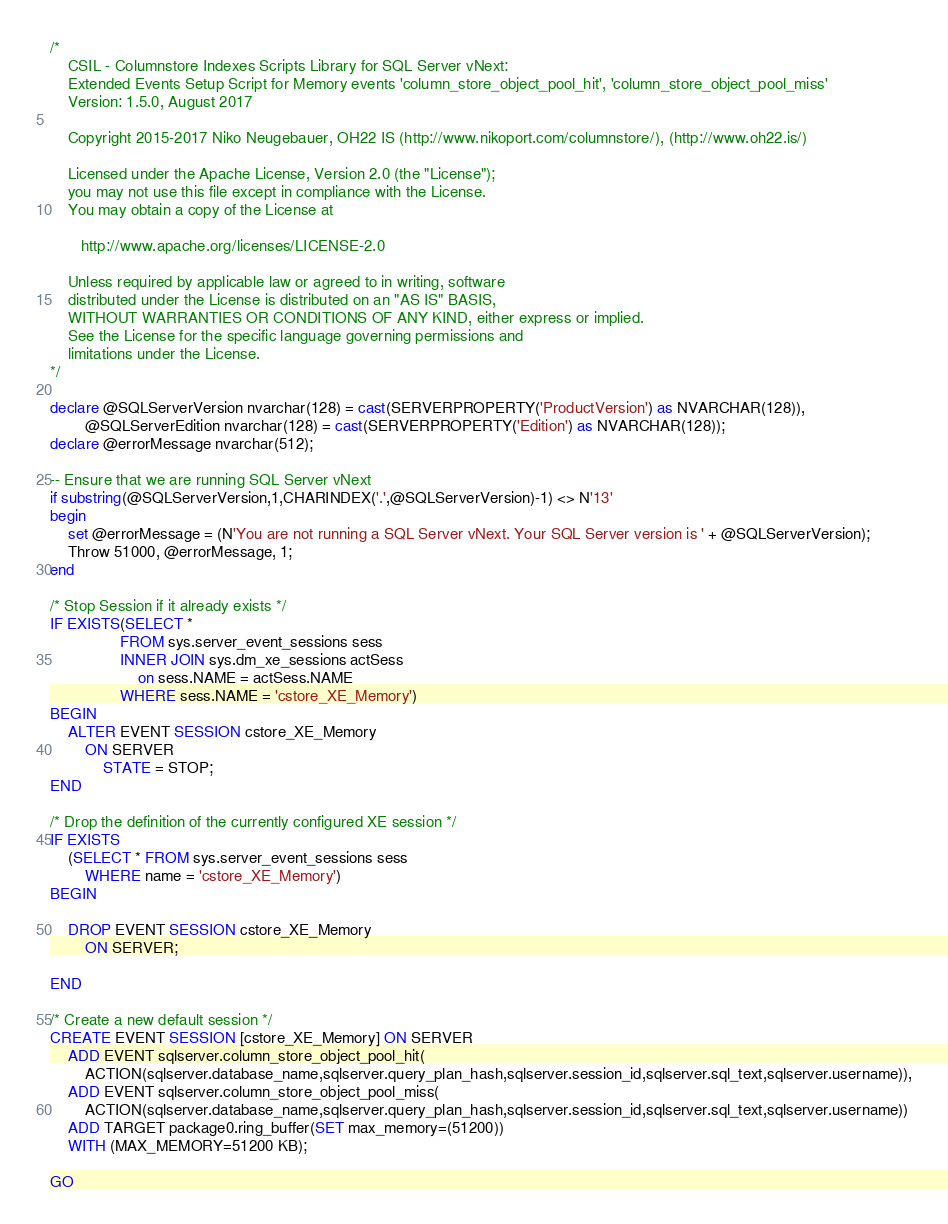Convert code to text. <code><loc_0><loc_0><loc_500><loc_500><_SQL_>/*
	CSIL - Columnstore Indexes Scripts Library for SQL Server vNext: 
	Extended Events Setup Script for Memory events 'column_store_object_pool_hit', 'column_store_object_pool_miss'
	Version: 1.5.0, August 2017

	Copyright 2015-2017 Niko Neugebauer, OH22 IS (http://www.nikoport.com/columnstore/), (http://www.oh22.is/)

	Licensed under the Apache License, Version 2.0 (the "License");
	you may not use this file except in compliance with the License.
	You may obtain a copy of the License at

       http://www.apache.org/licenses/LICENSE-2.0

    Unless required by applicable law or agreed to in writing, software
    distributed under the License is distributed on an "AS IS" BASIS,
    WITHOUT WARRANTIES OR CONDITIONS OF ANY KIND, either express or implied.
    See the License for the specific language governing permissions and
    limitations under the License.
*/

declare @SQLServerVersion nvarchar(128) = cast(SERVERPROPERTY('ProductVersion') as NVARCHAR(128)), 
		@SQLServerEdition nvarchar(128) = cast(SERVERPROPERTY('Edition') as NVARCHAR(128));
declare @errorMessage nvarchar(512);

-- Ensure that we are running SQL Server vNext
if substring(@SQLServerVersion,1,CHARINDEX('.',@SQLServerVersion)-1) <> N'13'
begin
	set @errorMessage = (N'You are not running a SQL Server vNext. Your SQL Server version is ' + @SQLServerVersion);
	Throw 51000, @errorMessage, 1;
end

/* Stop Session if it already exists */
IF EXISTS(SELECT *
				FROM sys.server_event_sessions sess
				INNER JOIN sys.dm_xe_sessions actSess
					on sess.NAME = actSess.NAME
				WHERE sess.NAME = 'cstore_XE_Memory')
BEGIN
	ALTER EVENT SESSION cstore_XE_Memory
		ON SERVER 
			STATE = STOP;
END

/* Drop the definition of the currently configured XE session */
IF EXISTS
    (SELECT * FROM sys.server_event_sessions sess
        WHERE name = 'cstore_XE_Memory')
BEGIN

    DROP EVENT SESSION cstore_XE_Memory
        ON SERVER;
	
END

/* Create a new default session */
CREATE EVENT SESSION [cstore_XE_Memory] ON SERVER 
	ADD EVENT sqlserver.column_store_object_pool_hit(
		ACTION(sqlserver.database_name,sqlserver.query_plan_hash,sqlserver.session_id,sqlserver.sql_text,sqlserver.username)),
	ADD EVENT sqlserver.column_store_object_pool_miss(
		ACTION(sqlserver.database_name,sqlserver.query_plan_hash,sqlserver.session_id,sqlserver.sql_text,sqlserver.username))
	ADD TARGET package0.ring_buffer(SET max_memory=(51200))
	WITH (MAX_MEMORY=51200 KB);

GO



</code> 